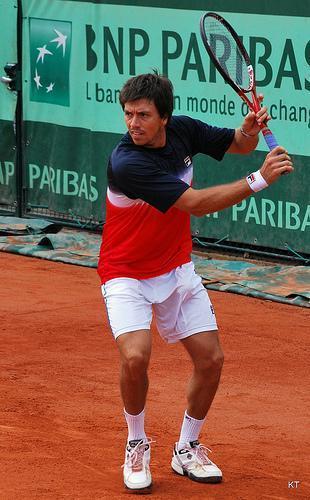How many shoes are there?
Give a very brief answer. 2. 